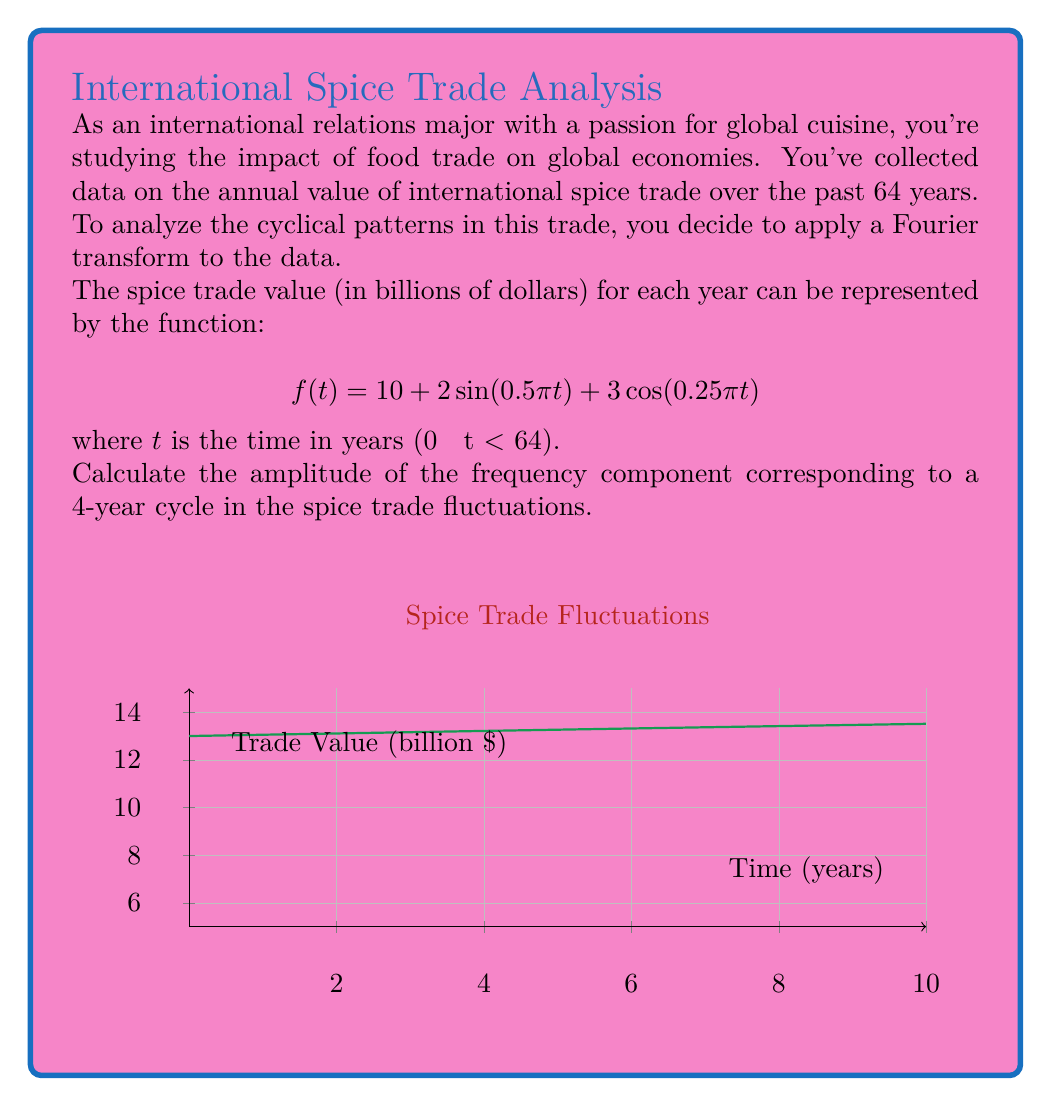Could you help me with this problem? Let's approach this step-by-step:

1) The Fourier transform of $f(t)$ is given by:

   $$F(\omega) = \int_{-\infty}^{\infty} f(t) e^{-i\omega t} dt$$

2) In our case, we're interested in the frequency component corresponding to a 4-year cycle. The angular frequency for a 4-year cycle is:

   $$\omega = \frac{2\pi}{T} = \frac{2\pi}{4} = \frac{\pi}{2}$$

3) Now, let's break down our function:
   
   $$f(t) = 10 + 2\sin(0.5\pi t) + 3\cos(0.25\pi t)$$

4) The constant term 10 will only contribute to the DC component (ω = 0), so we can ignore it for this frequency.

5) For the sin term:
   
   $$2\sin(0.5\pi t) = \frac{2}{2i}(e^{i0.5\pi t} - e^{-i0.5\pi t})$$

   This corresponds to frequencies ω = ±0.5π, not our target frequency.

6) For the cos term:
   
   $$3\cos(0.25\pi t) = \frac{3}{2}(e^{i0.25\pi t} + e^{-i0.25\pi t})$$

   This corresponds to frequencies ω = ±0.25π, which includes our target frequency of π/2.

7) The amplitude of the frequency component at ω = π/2 is half of the coefficient of the cosine term:

   $$\text{Amplitude} = \frac{3}{2}$$
Answer: $\frac{3}{2}$ 